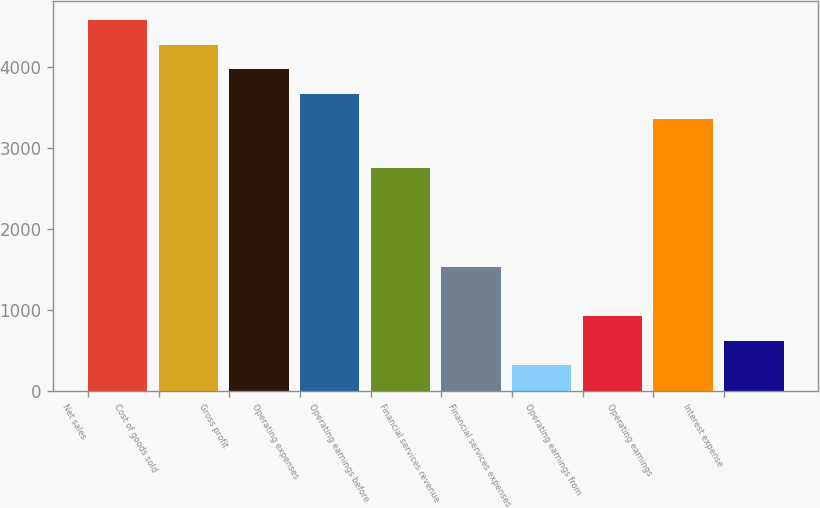<chart> <loc_0><loc_0><loc_500><loc_500><bar_chart><fcel>Net sales<fcel>Cost of goods sold<fcel>Gross profit<fcel>Operating expenses<fcel>Operating earnings before<fcel>Financial services revenue<fcel>Financial services expenses<fcel>Operating earnings from<fcel>Operating earnings<fcel>Interest expense<nl><fcel>4580.05<fcel>4275.34<fcel>3970.63<fcel>3665.92<fcel>2751.79<fcel>1532.95<fcel>314.11<fcel>923.53<fcel>3361.21<fcel>618.82<nl></chart> 